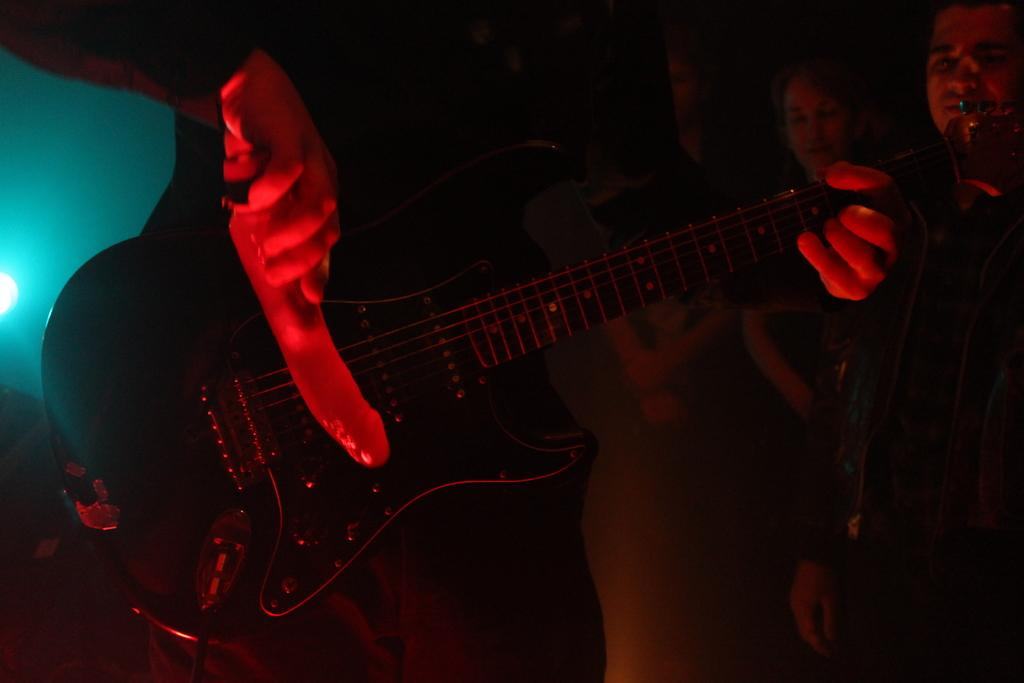What is the man in the image doing? The man is playing a guitar in the image. Can you describe the people visible in the image? There are people visible in the image, but their specific actions or characteristics are not mentioned in the provided facts. What type of bean is the man using to play the guitar in the image? There is no bean present in the image, and the man is using a guitar, not a bean, to make music. 